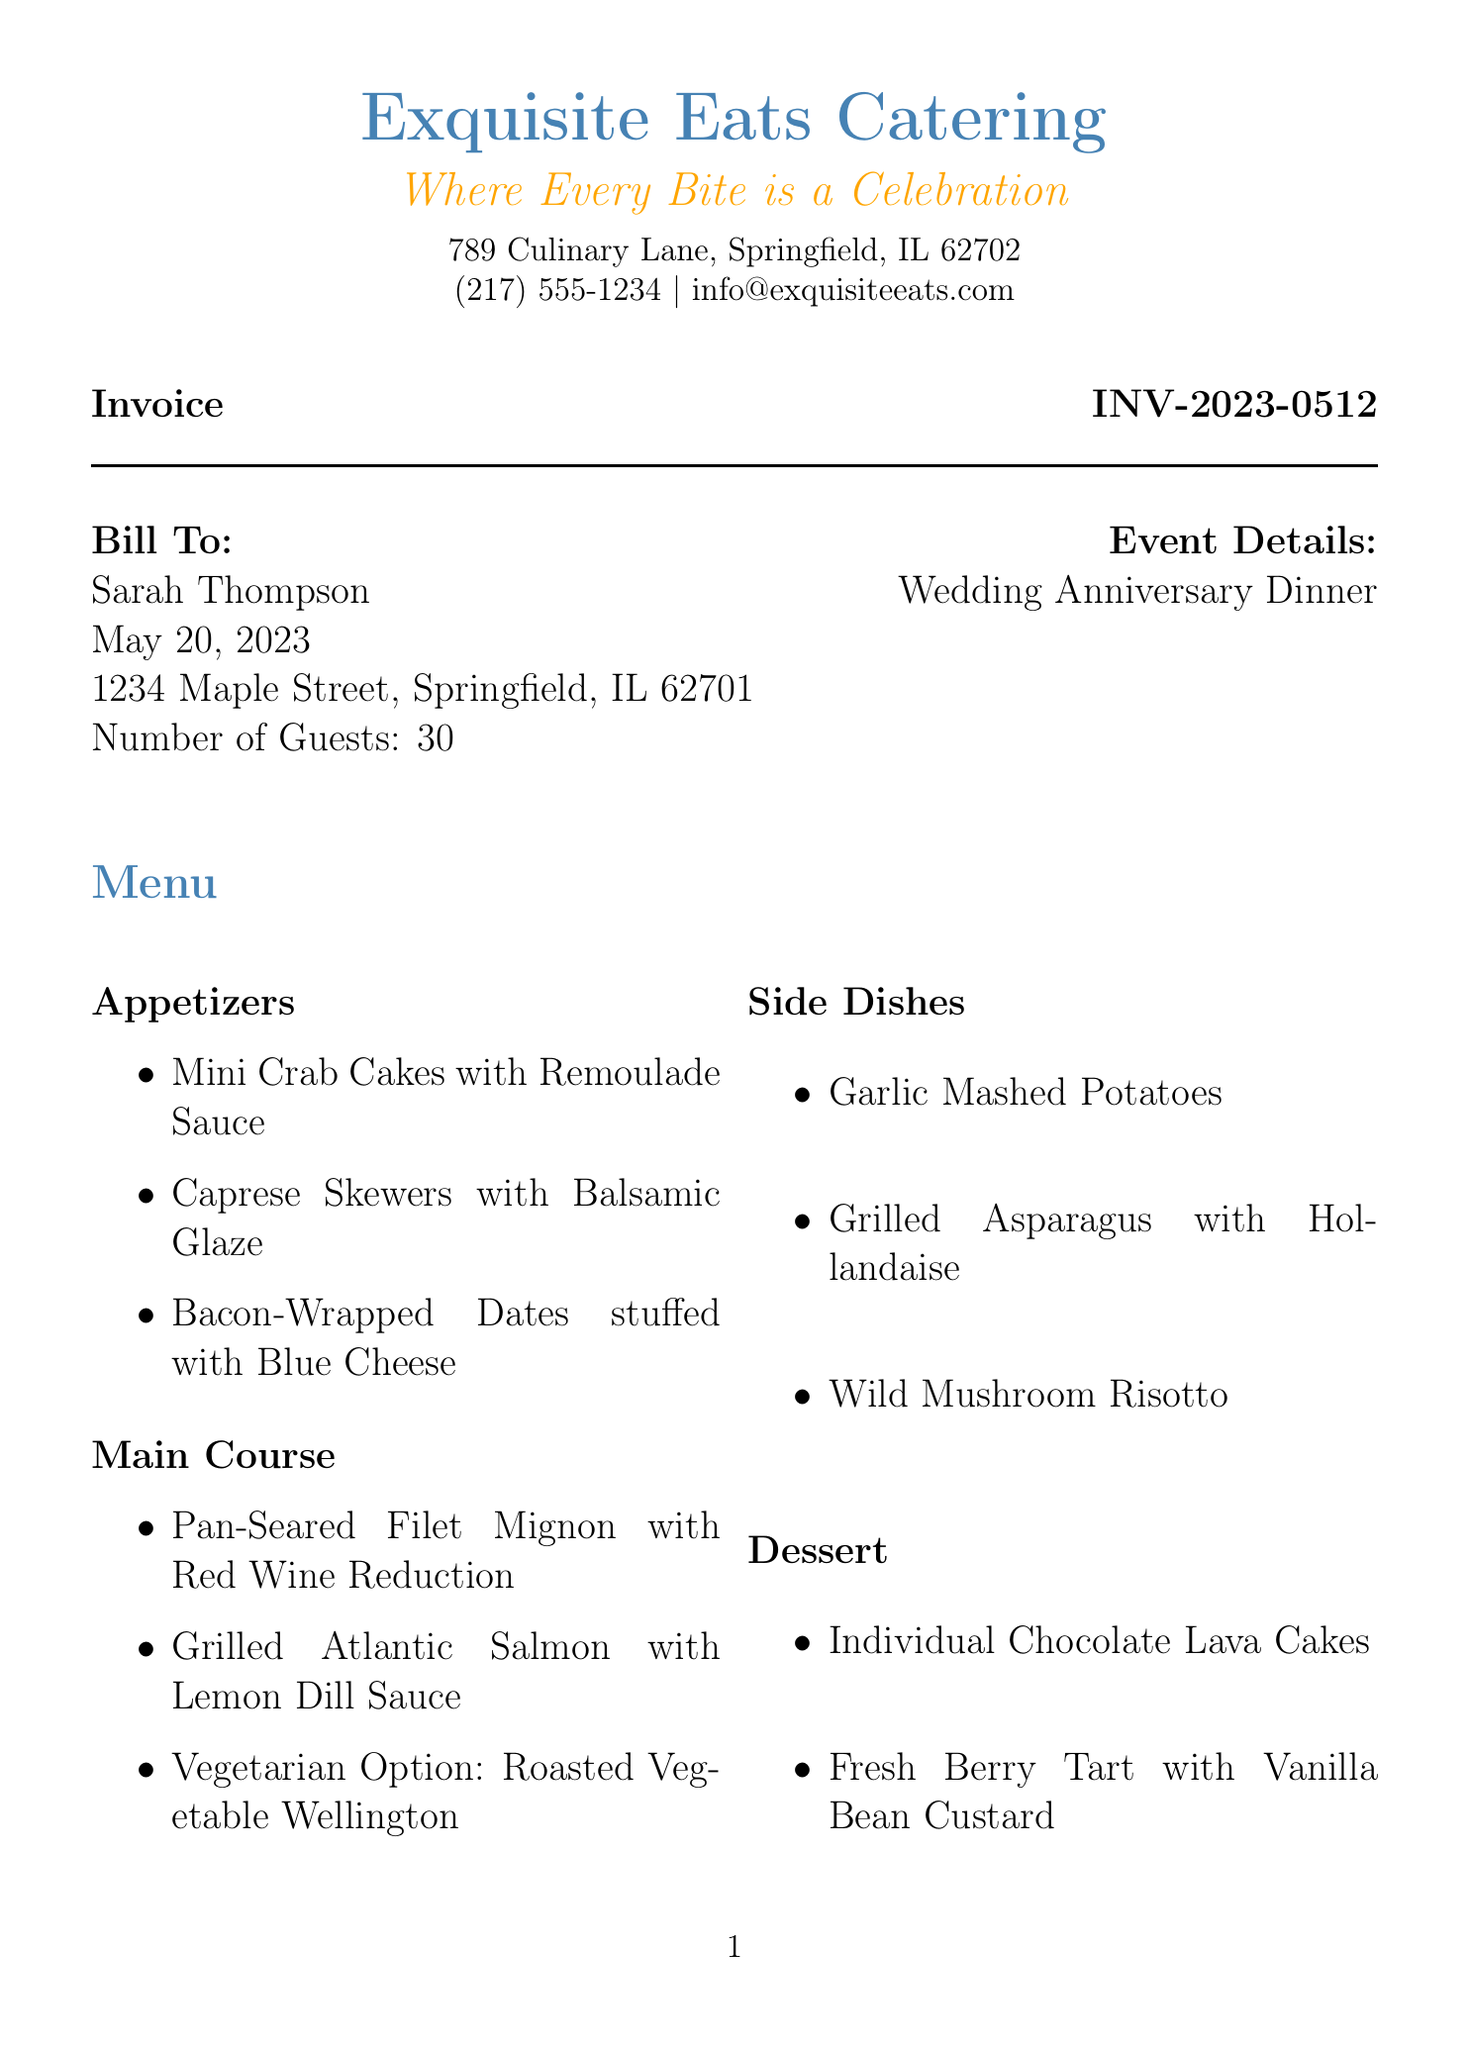what is the invoice number? The invoice number is a unique identifier for this document, found in the header section.
Answer: INV-2023-0512 what is the total due amount? The total due amount is the sum of the subtotal and tax, stated at the bottom of the invoice.
Answer: $5499.10 who is the catering company? This is the name of the business providing the catering service, listed at the top of the document.
Answer: Exquisite Eats Catering how many guests are invited? This information is provided in the event details section of the invoice.
Answer: 30 what is the date of the wedding anniversary dinner? This is the date the event is scheduled for, mentioned in the event details.
Answer: May 20, 2023 how much is the deposit due upon booking? The deposit amount is indicated in the payment terms section of the invoice.
Answer: 50% what is the fee for menu customization and consultation? This fee is listed among the additional services provided in the pricing section.
Answer: $250.00 how many servers are included in the staffing fees? This information can be deduced from the staff listing and their respective quantities.
Answer: 4 what is the tax rate applied on the invoice? The document specifies the tax rate applicable to the total amount.
Answer: 8.25% 